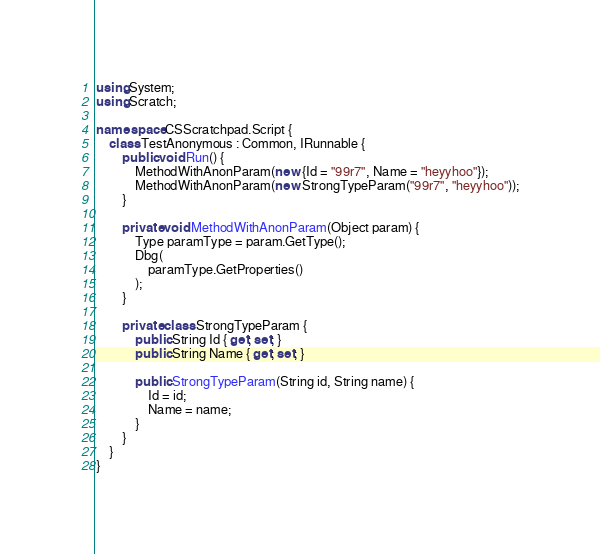Convert code to text. <code><loc_0><loc_0><loc_500><loc_500><_C#_>using System;
using Scratch;

namespace CSScratchpad.Script {
    class TestAnonymous : Common, IRunnable {
        public void Run() {
            MethodWithAnonParam(new {Id = "99r7", Name = "heyyhoo"});
            MethodWithAnonParam(new StrongTypeParam("99r7", "heyyhoo"));
        }

        private void MethodWithAnonParam(Object param) {
            Type paramType = param.GetType();
            Dbg(
                paramType.GetProperties()
            );
        }

        private class StrongTypeParam {
            public String Id { get; set; }
            public String Name { get; set; }

            public StrongTypeParam(String id, String name) {
                Id = id;
                Name = name;
            }
        }
    }
}
</code> 